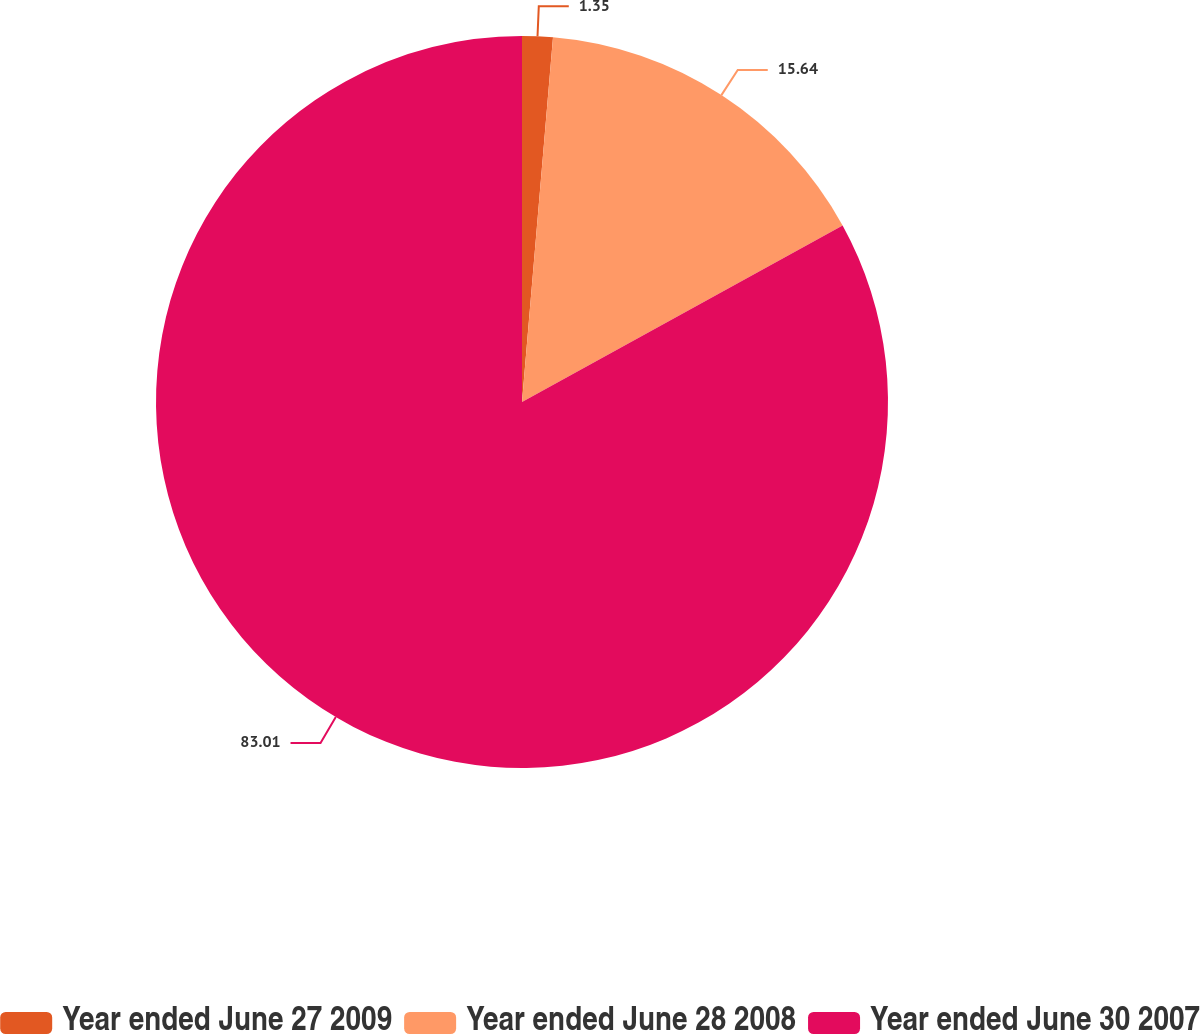Convert chart. <chart><loc_0><loc_0><loc_500><loc_500><pie_chart><fcel>Year ended June 27 2009<fcel>Year ended June 28 2008<fcel>Year ended June 30 2007<nl><fcel>1.35%<fcel>15.64%<fcel>83.01%<nl></chart> 